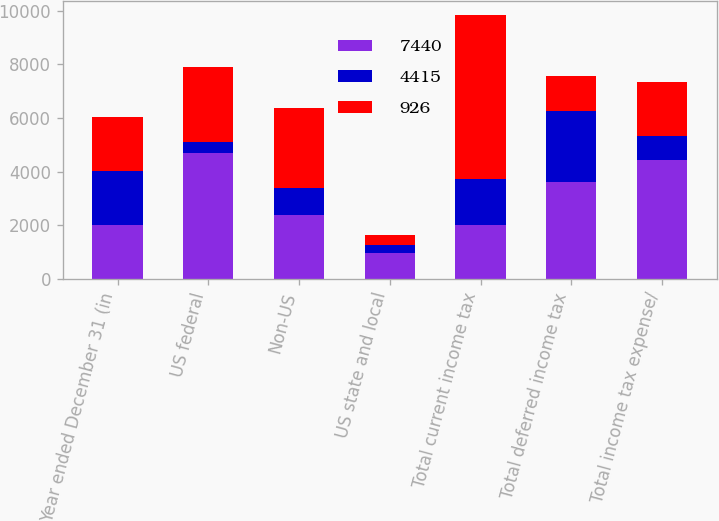Convert chart to OTSL. <chart><loc_0><loc_0><loc_500><loc_500><stacked_bar_chart><ecel><fcel>Year ended December 31 (in<fcel>US federal<fcel>Non-US<fcel>US state and local<fcel>Total current income tax<fcel>Total deferred income tax<fcel>Total income tax expense/<nl><fcel>7440<fcel>2009<fcel>4698<fcel>2368<fcel>971<fcel>2008<fcel>3622<fcel>4415<nl><fcel>4415<fcel>2008<fcel>395<fcel>1009<fcel>307<fcel>1711<fcel>2637<fcel>926<nl><fcel>926<fcel>2007<fcel>2805<fcel>2985<fcel>343<fcel>6133<fcel>1307<fcel>2008<nl></chart> 